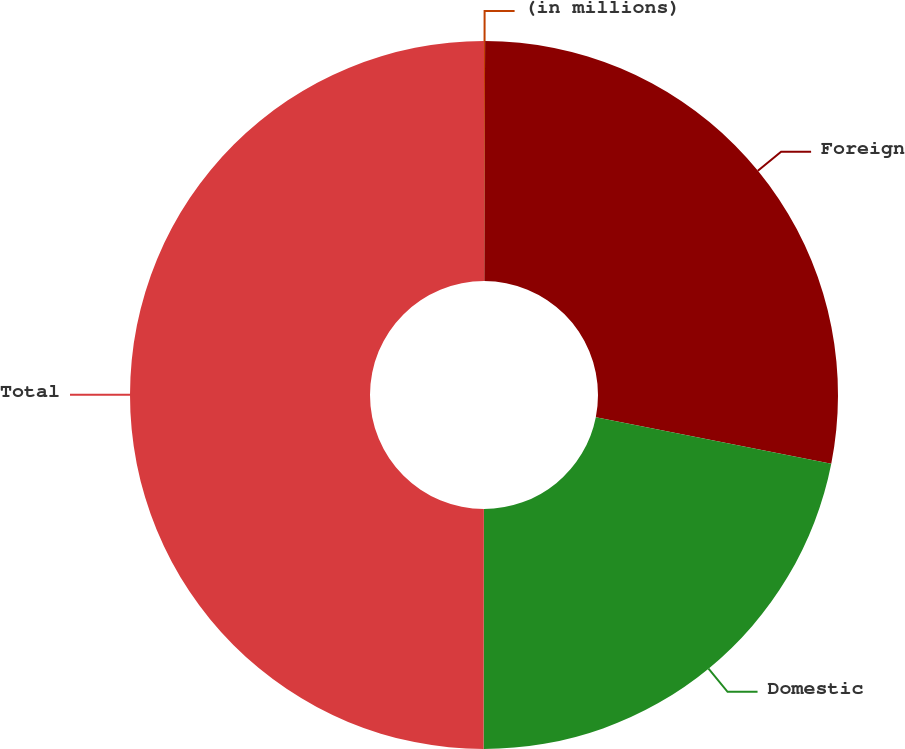<chart> <loc_0><loc_0><loc_500><loc_500><pie_chart><fcel>(in millions)<fcel>Foreign<fcel>Domestic<fcel>Total<nl><fcel>0.05%<fcel>28.06%<fcel>21.91%<fcel>49.98%<nl></chart> 